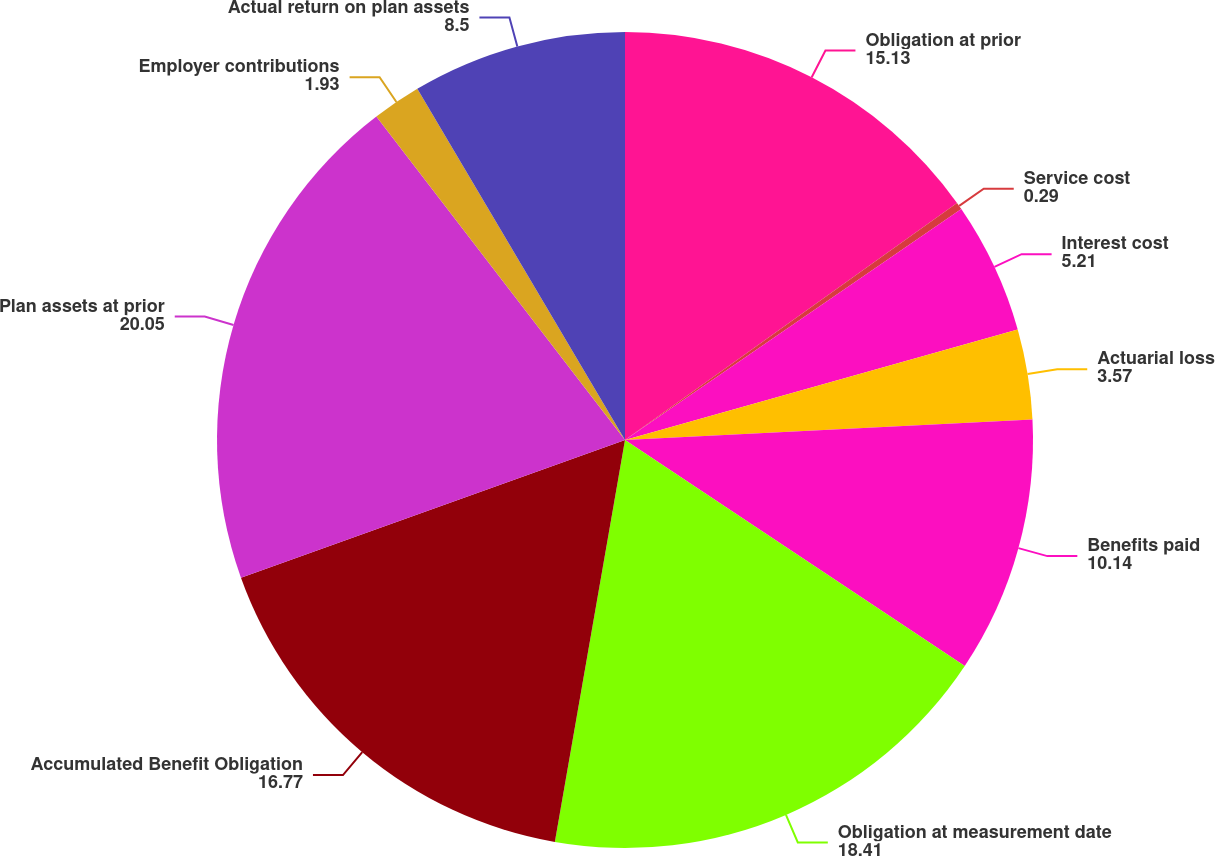Convert chart. <chart><loc_0><loc_0><loc_500><loc_500><pie_chart><fcel>Obligation at prior<fcel>Service cost<fcel>Interest cost<fcel>Actuarial loss<fcel>Benefits paid<fcel>Obligation at measurement date<fcel>Accumulated Benefit Obligation<fcel>Plan assets at prior<fcel>Employer contributions<fcel>Actual return on plan assets<nl><fcel>15.13%<fcel>0.29%<fcel>5.21%<fcel>3.57%<fcel>10.14%<fcel>18.41%<fcel>16.77%<fcel>20.05%<fcel>1.93%<fcel>8.5%<nl></chart> 